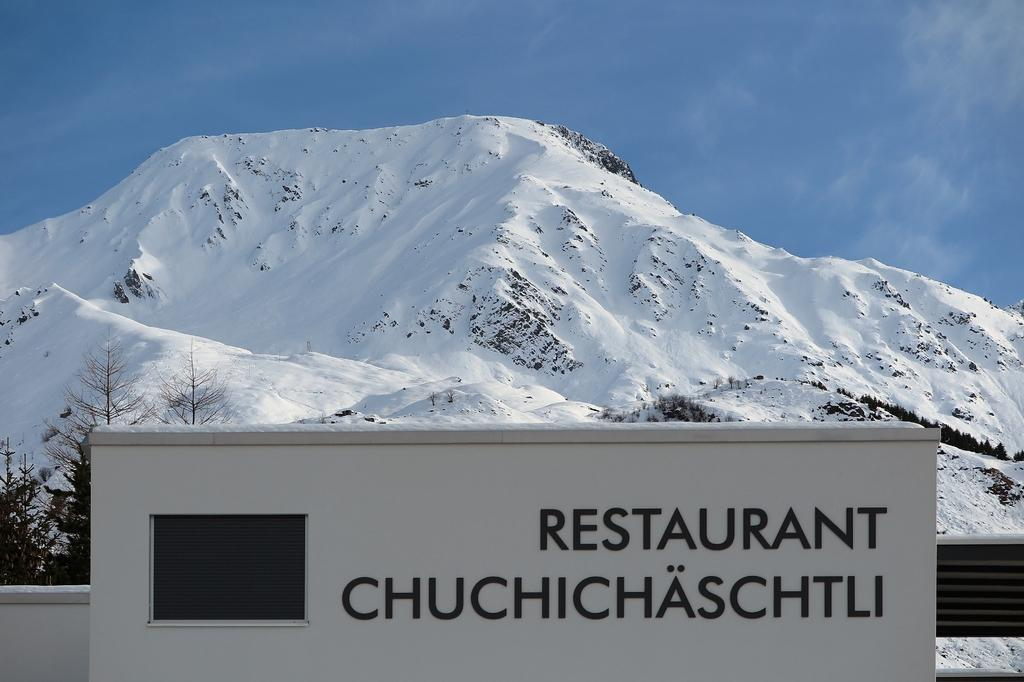<image>
Render a clear and concise summary of the photo. sign in front of a white mountain that says "Restaurant Chuchichaschtli". 